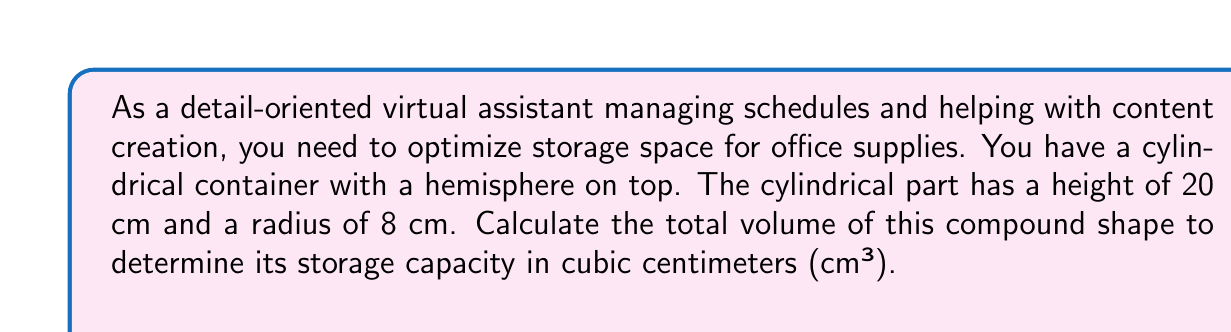Provide a solution to this math problem. To find the total volume of this compound shape, we need to calculate the volumes of the cylinder and hemisphere separately, then sum them up.

1. Volume of the cylinder:
   The formula for the volume of a cylinder is $V_{cylinder} = \pi r^2 h$
   where $r$ is the radius and $h$ is the height.
   
   $V_{cylinder} = \pi \cdot 8^2 \cdot 20 = 1280\pi$ cm³

2. Volume of the hemisphere:
   The formula for the volume of a hemisphere is $V_{hemisphere} = \frac{2}{3}\pi r^3$
   where $r$ is the radius.
   
   $V_{hemisphere} = \frac{2}{3}\pi \cdot 8^3 = \frac{1024\pi}{3}$ cm³

3. Total volume:
   $V_{total} = V_{cylinder} + V_{hemisphere}$
   $V_{total} = 1280\pi + \frac{1024\pi}{3}$
   $V_{total} = \frac{3840\pi + 1024\pi}{3} = \frac{4864\pi}{3}$ cm³

To get a numerical value, we can use $\pi \approx 3.14159$:

$V_{total} \approx \frac{4864 \cdot 3.14159}{3} \approx 5087.62$ cm³
Answer: The total volume of the compound shape is $\frac{4864\pi}{3}$ cm³ or approximately 5087.62 cm³. 